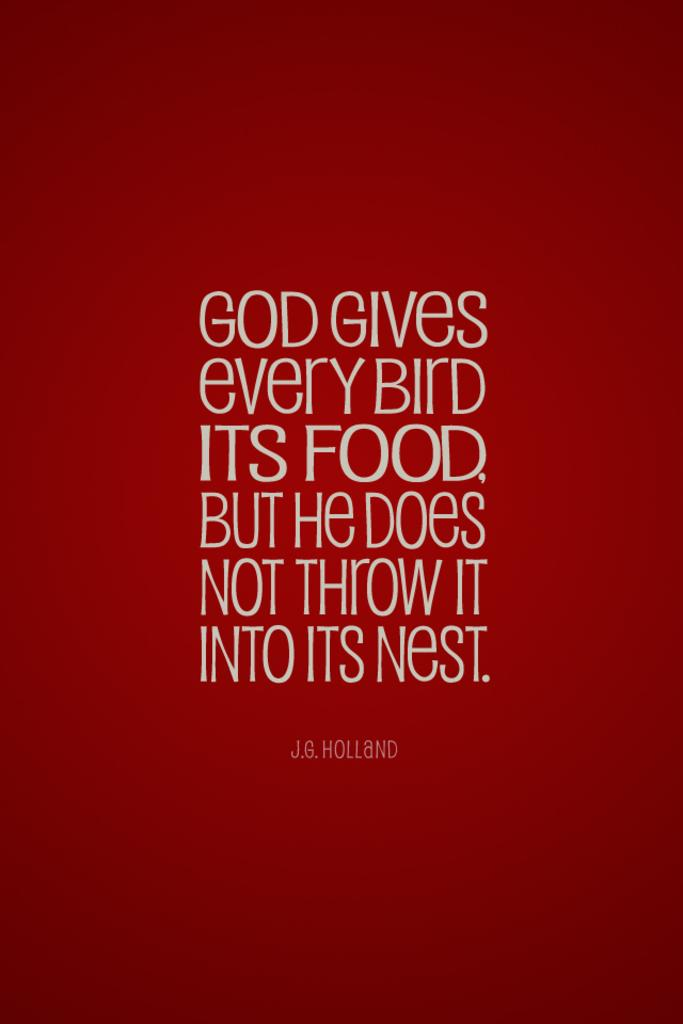<image>
Create a compact narrative representing the image presented. A quote by J.G. Holland is printed in white lettering on a red background. 